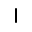<formula> <loc_0><loc_0><loc_500><loc_500>|</formula> 